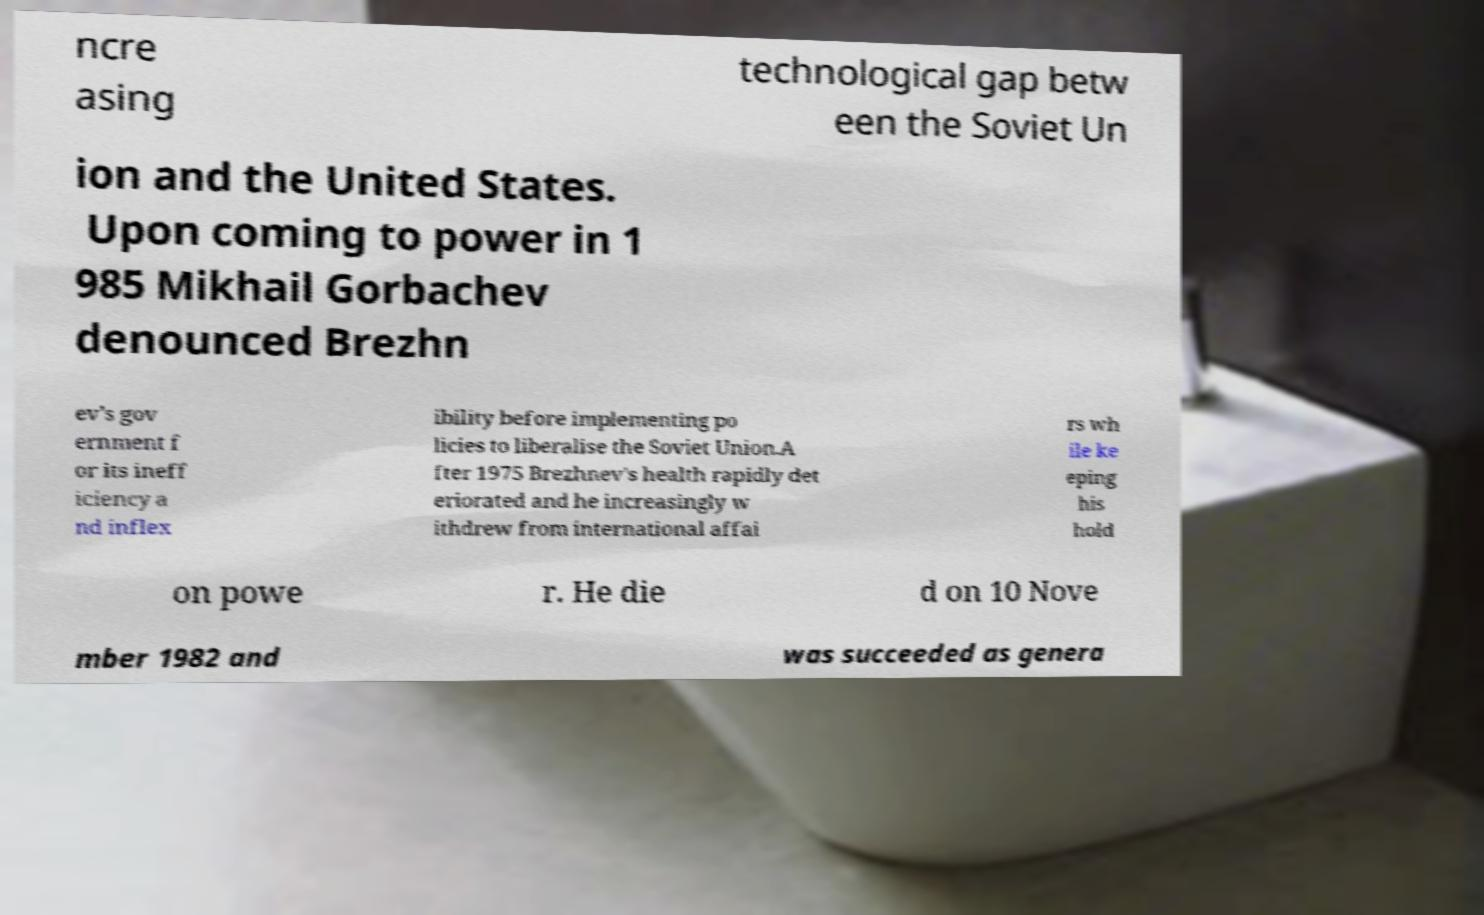Please read and relay the text visible in this image. What does it say? ncre asing technological gap betw een the Soviet Un ion and the United States. Upon coming to power in 1 985 Mikhail Gorbachev denounced Brezhn ev's gov ernment f or its ineff iciency a nd inflex ibility before implementing po licies to liberalise the Soviet Union.A fter 1975 Brezhnev's health rapidly det eriorated and he increasingly w ithdrew from international affai rs wh ile ke eping his hold on powe r. He die d on 10 Nove mber 1982 and was succeeded as genera 